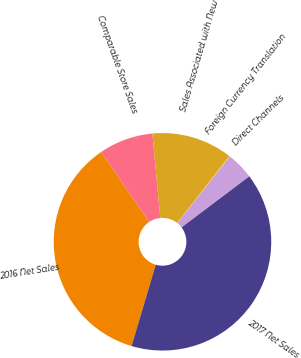<chart> <loc_0><loc_0><loc_500><loc_500><pie_chart><fcel>2016 Net Sales<fcel>Comparable Store Sales<fcel>Sales Associated with New<fcel>Foreign Currency Translation<fcel>Direct Channels<fcel>2017 Net Sales<nl><fcel>35.9%<fcel>8.04%<fcel>12.0%<fcel>0.11%<fcel>4.08%<fcel>39.87%<nl></chart> 